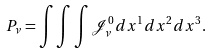Convert formula to latex. <formula><loc_0><loc_0><loc_500><loc_500>P _ { \nu } = \int \int \int \mathcal { J } _ { \nu } ^ { 0 } d x ^ { 1 } d x ^ { 2 } d x ^ { 3 } .</formula> 